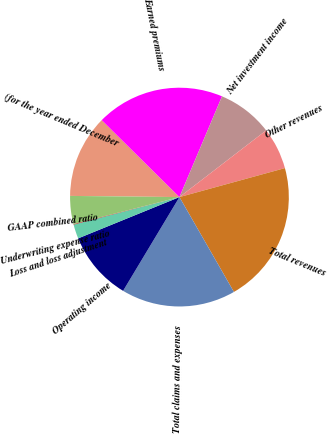Convert chart. <chart><loc_0><loc_0><loc_500><loc_500><pie_chart><fcel>(for the year ended December<fcel>Earned premiums<fcel>Net investment income<fcel>Other revenues<fcel>Total revenues<fcel>Total claims and expenses<fcel>Operating income<fcel>Loss and loss adjustment<fcel>Underwriting expense ratio<fcel>GAAP combined ratio<nl><fcel>12.25%<fcel>18.94%<fcel>8.2%<fcel>6.17%<fcel>20.97%<fcel>16.91%<fcel>10.23%<fcel>2.11%<fcel>0.08%<fcel>4.14%<nl></chart> 